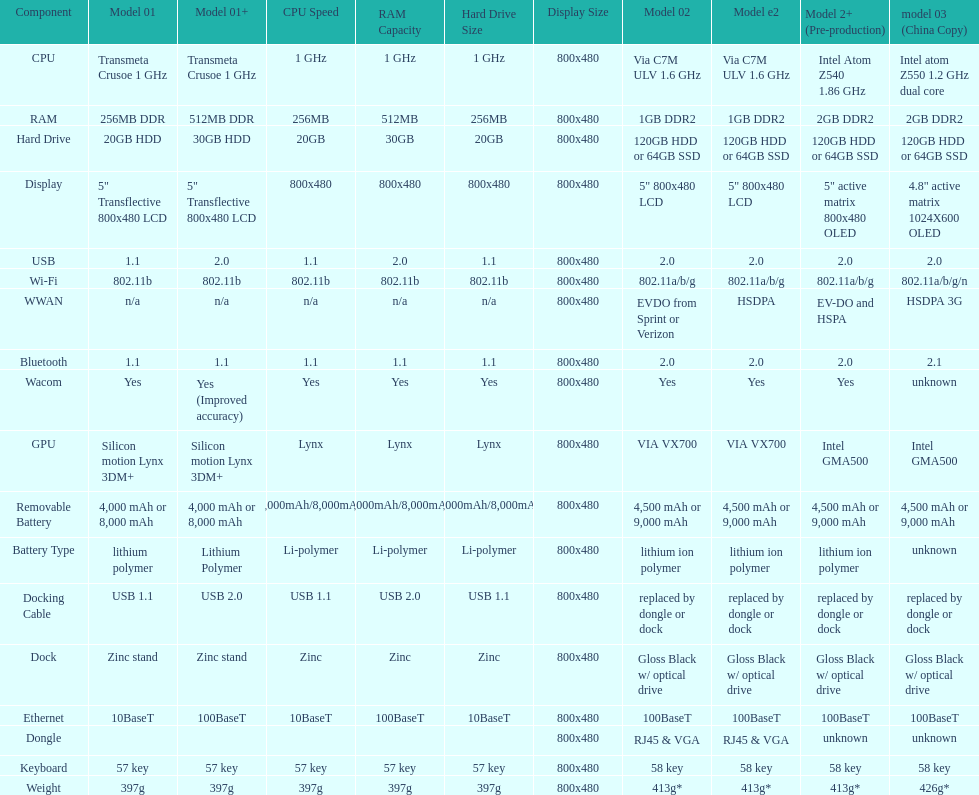How many models have 1.6ghz? 2. 